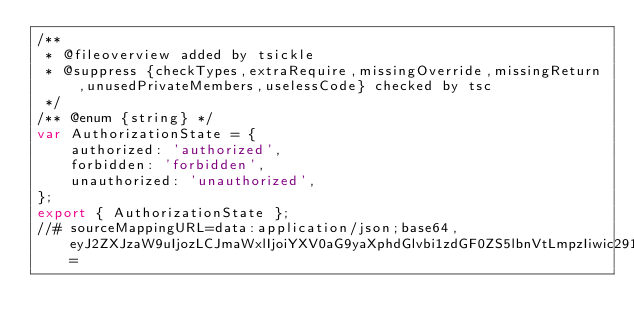Convert code to text. <code><loc_0><loc_0><loc_500><loc_500><_JavaScript_>/**
 * @fileoverview added by tsickle
 * @suppress {checkTypes,extraRequire,missingOverride,missingReturn,unusedPrivateMembers,uselessCode} checked by tsc
 */
/** @enum {string} */
var AuthorizationState = {
    authorized: 'authorized',
    forbidden: 'forbidden',
    unauthorized: 'unauthorized',
};
export { AuthorizationState };
//# sourceMappingURL=data:application/json;base64,eyJ2ZXJzaW9uIjozLCJmaWxlIjoiYXV0aG9yaXphdGlvbi1zdGF0ZS5lbnVtLmpzIiwic291cmNlUm9vdCI6Im5nOi8vYW5ndWxhci1hdXRoLW9pZGMtY2xpZW50LyIsInNvdXJjZXMiOlsibGliL21vZGVscy9hdXRob3JpemF0aW9uLXN0YXRlLmVudW0udHMiXSwibmFtZXMiOltdLCJtYXBwaW5ncyI6Ijs7Ozs7O0lBQ0ksWUFBYSxZQUFZO0lBQ3pCLFdBQVksV0FBVztJQUN2QixjQUFlLGNBQWMiLCJzb3VyY2VzQ29udGVudCI6WyJleHBvcnQgZW51bSBBdXRob3JpemF0aW9uU3RhdGUge1xyXG4gICAgYXV0aG9yaXplZCA9ICdhdXRob3JpemVkJyxcclxuICAgIGZvcmJpZGRlbiA9ICdmb3JiaWRkZW4nLFxyXG4gICAgdW5hdXRob3JpemVkID0gJ3VuYXV0aG9yaXplZCdcclxufVxyXG4iXX0=</code> 